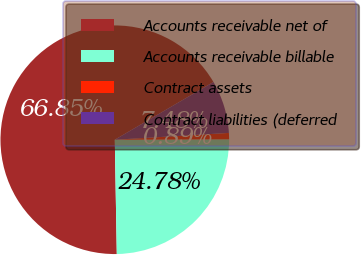<chart> <loc_0><loc_0><loc_500><loc_500><pie_chart><fcel>Accounts receivable net of<fcel>Accounts receivable billable<fcel>Contract assets<fcel>Contract liabilities (deferred<nl><fcel>66.85%<fcel>24.78%<fcel>0.89%<fcel>7.48%<nl></chart> 